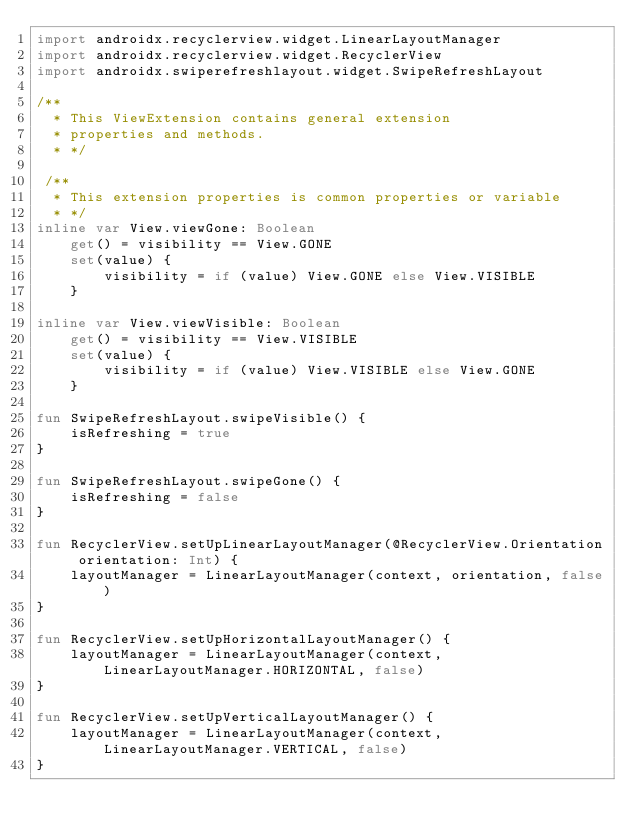<code> <loc_0><loc_0><loc_500><loc_500><_Kotlin_>import androidx.recyclerview.widget.LinearLayoutManager
import androidx.recyclerview.widget.RecyclerView
import androidx.swiperefreshlayout.widget.SwipeRefreshLayout

/**
  * This ViewExtension contains general extension
  * properties and methods.
  * */

 /**
  * This extension properties is common properties or variable
  * */
inline var View.viewGone: Boolean
    get() = visibility == View.GONE
    set(value) {
        visibility = if (value) View.GONE else View.VISIBLE
    }

inline var View.viewVisible: Boolean
    get() = visibility == View.VISIBLE
    set(value) {
        visibility = if (value) View.VISIBLE else View.GONE
    }

fun SwipeRefreshLayout.swipeVisible() {
    isRefreshing = true
}

fun SwipeRefreshLayout.swipeGone() {
    isRefreshing = false
}

fun RecyclerView.setUpLinearLayoutManager(@RecyclerView.Orientation orientation: Int) {
    layoutManager = LinearLayoutManager(context, orientation, false)
}

fun RecyclerView.setUpHorizontalLayoutManager() {
    layoutManager = LinearLayoutManager(context, LinearLayoutManager.HORIZONTAL, false)
}

fun RecyclerView.setUpVerticalLayoutManager() {
    layoutManager = LinearLayoutManager(context, LinearLayoutManager.VERTICAL, false)
}

</code> 